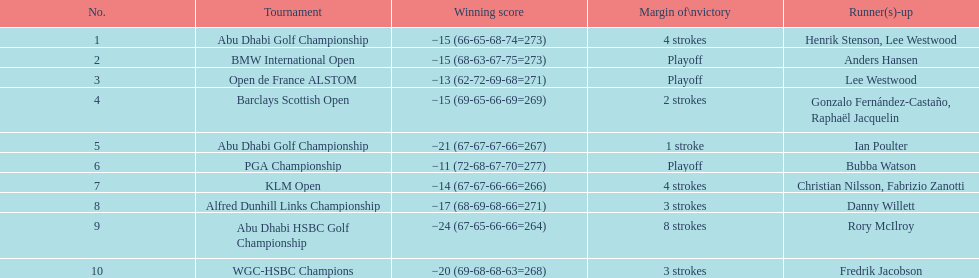In the pga championship, who secured the best score? Bubba Watson. 